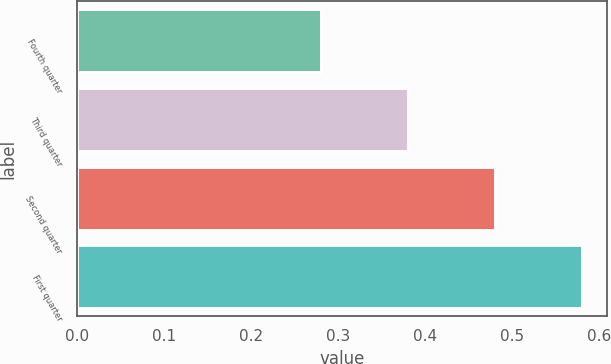Convert chart to OTSL. <chart><loc_0><loc_0><loc_500><loc_500><bar_chart><fcel>Fourth quarter<fcel>Third quarter<fcel>Second quarter<fcel>First quarter<nl><fcel>0.28<fcel>0.38<fcel>0.48<fcel>0.58<nl></chart> 